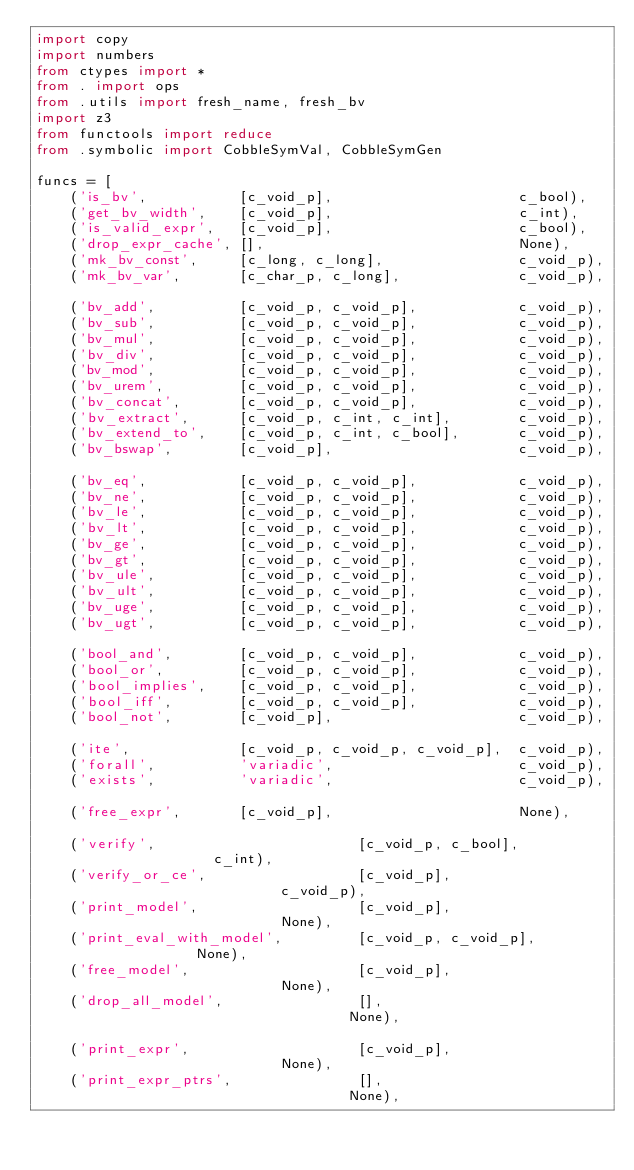Convert code to text. <code><loc_0><loc_0><loc_500><loc_500><_Python_>import copy
import numbers
from ctypes import *
from . import ops
from .utils import fresh_name, fresh_bv
import z3
from functools import reduce
from .symbolic import CobbleSymVal, CobbleSymGen

funcs = [
    ('is_bv',           [c_void_p],                      c_bool),
    ('get_bv_width',    [c_void_p],                      c_int),
    ('is_valid_expr',   [c_void_p],                      c_bool),
    ('drop_expr_cache', [],                              None),
    ('mk_bv_const',     [c_long, c_long],                c_void_p),
    ('mk_bv_var',       [c_char_p, c_long],              c_void_p),

    ('bv_add',          [c_void_p, c_void_p],            c_void_p),
    ('bv_sub',          [c_void_p, c_void_p],            c_void_p),
    ('bv_mul',          [c_void_p, c_void_p],            c_void_p),
    ('bv_div',          [c_void_p, c_void_p],            c_void_p),
    ('bv_mod',          [c_void_p, c_void_p],            c_void_p),
    ('bv_urem',         [c_void_p, c_void_p],            c_void_p),
    ('bv_concat',       [c_void_p, c_void_p],            c_void_p),
    ('bv_extract',      [c_void_p, c_int, c_int],        c_void_p),
    ('bv_extend_to',    [c_void_p, c_int, c_bool],       c_void_p),
    ('bv_bswap',        [c_void_p],                      c_void_p),

    ('bv_eq',           [c_void_p, c_void_p],            c_void_p),
    ('bv_ne',           [c_void_p, c_void_p],            c_void_p),
    ('bv_le',           [c_void_p, c_void_p],            c_void_p),
    ('bv_lt',           [c_void_p, c_void_p],            c_void_p),
    ('bv_ge',           [c_void_p, c_void_p],            c_void_p),
    ('bv_gt',           [c_void_p, c_void_p],            c_void_p),
    ('bv_ule',          [c_void_p, c_void_p],            c_void_p),
    ('bv_ult',          [c_void_p, c_void_p],            c_void_p),
    ('bv_uge',          [c_void_p, c_void_p],            c_void_p),
    ('bv_ugt',          [c_void_p, c_void_p],            c_void_p),

    ('bool_and',        [c_void_p, c_void_p],            c_void_p),
    ('bool_or',         [c_void_p, c_void_p],            c_void_p),
    ('bool_implies',    [c_void_p, c_void_p],            c_void_p),
    ('bool_iff',        [c_void_p, c_void_p],            c_void_p),
    ('bool_not',        [c_void_p],                      c_void_p),

    ('ite',             [c_void_p, c_void_p, c_void_p],  c_void_p),
    ('forall',          'variadic',                      c_void_p),
    ('exists',          'variadic',                      c_void_p),

    ('free_expr',       [c_void_p],                      None),

    ('verify',                        [c_void_p, c_bool],              c_int),
    ('verify_or_ce',                  [c_void_p],                      c_void_p),
    ('print_model',                   [c_void_p],                      None),
    ('print_eval_with_model',         [c_void_p, c_void_p],            None),
    ('free_model',                    [c_void_p],                      None),
    ('drop_all_model',                [],                              None),

    ('print_expr',                    [c_void_p],                      None),
    ('print_expr_ptrs',               [],                              None),
</code> 